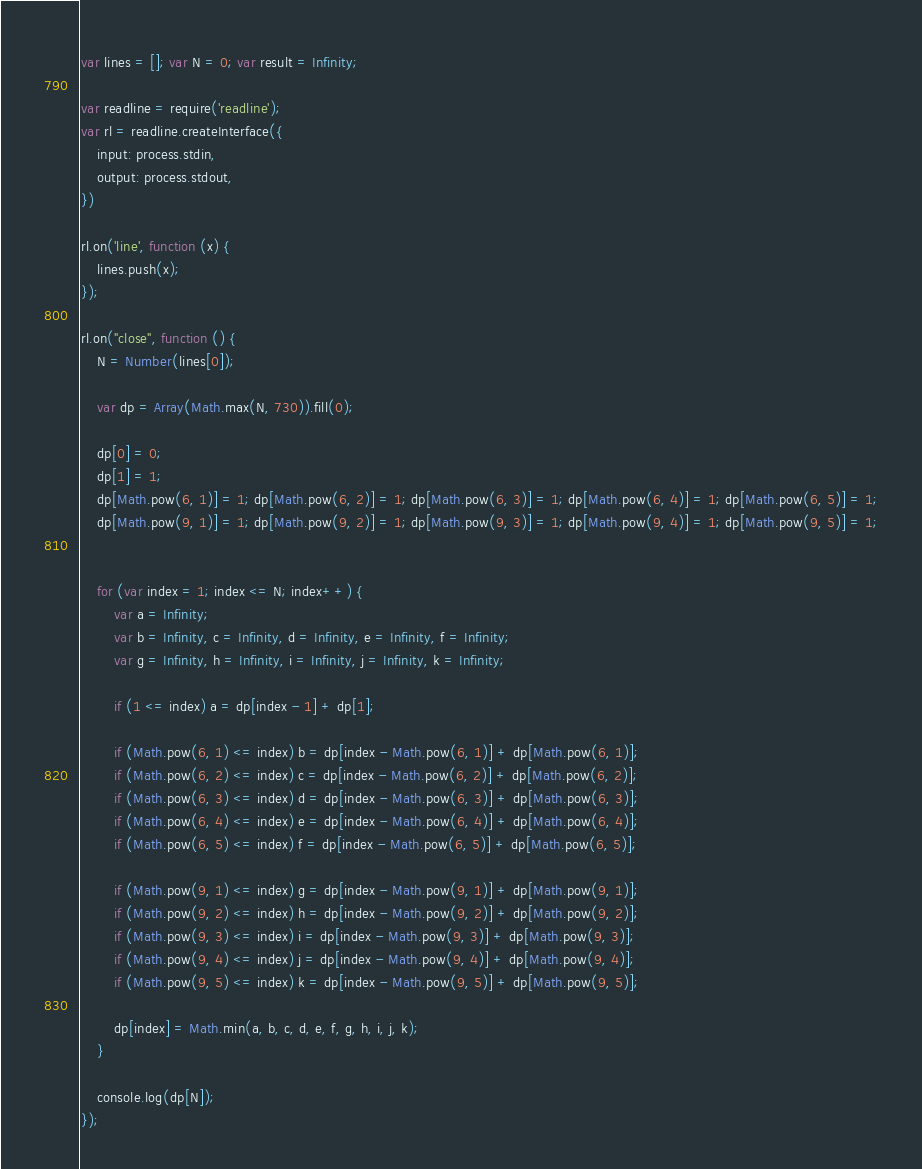<code> <loc_0><loc_0><loc_500><loc_500><_JavaScript_>var lines = []; var N = 0; var result = Infinity;

var readline = require('readline');
var rl = readline.createInterface({
    input: process.stdin,
    output: process.stdout,
})

rl.on('line', function (x) {
    lines.push(x);
});

rl.on("close", function () {
    N = Number(lines[0]);

    var dp = Array(Math.max(N, 730)).fill(0);

    dp[0] = 0;
    dp[1] = 1;
    dp[Math.pow(6, 1)] = 1; dp[Math.pow(6, 2)] = 1; dp[Math.pow(6, 3)] = 1; dp[Math.pow(6, 4)] = 1; dp[Math.pow(6, 5)] = 1;
    dp[Math.pow(9, 1)] = 1; dp[Math.pow(9, 2)] = 1; dp[Math.pow(9, 3)] = 1; dp[Math.pow(9, 4)] = 1; dp[Math.pow(9, 5)] = 1;


    for (var index = 1; index <= N; index++) {
        var a = Infinity;
        var b = Infinity, c = Infinity, d = Infinity, e = Infinity, f = Infinity;
        var g = Infinity, h = Infinity, i = Infinity, j = Infinity, k = Infinity;

        if (1 <= index) a = dp[index - 1] + dp[1];

        if (Math.pow(6, 1) <= index) b = dp[index - Math.pow(6, 1)] + dp[Math.pow(6, 1)];
        if (Math.pow(6, 2) <= index) c = dp[index - Math.pow(6, 2)] + dp[Math.pow(6, 2)];
        if (Math.pow(6, 3) <= index) d = dp[index - Math.pow(6, 3)] + dp[Math.pow(6, 3)];
        if (Math.pow(6, 4) <= index) e = dp[index - Math.pow(6, 4)] + dp[Math.pow(6, 4)];
        if (Math.pow(6, 5) <= index) f = dp[index - Math.pow(6, 5)] + dp[Math.pow(6, 5)];

        if (Math.pow(9, 1) <= index) g = dp[index - Math.pow(9, 1)] + dp[Math.pow(9, 1)];
        if (Math.pow(9, 2) <= index) h = dp[index - Math.pow(9, 2)] + dp[Math.pow(9, 2)];
        if (Math.pow(9, 3) <= index) i = dp[index - Math.pow(9, 3)] + dp[Math.pow(9, 3)];
        if (Math.pow(9, 4) <= index) j = dp[index - Math.pow(9, 4)] + dp[Math.pow(9, 4)];
        if (Math.pow(9, 5) <= index) k = dp[index - Math.pow(9, 5)] + dp[Math.pow(9, 5)];

        dp[index] = Math.min(a, b, c, d, e, f, g, h, i, j, k);
    }

    console.log(dp[N]);
});
</code> 